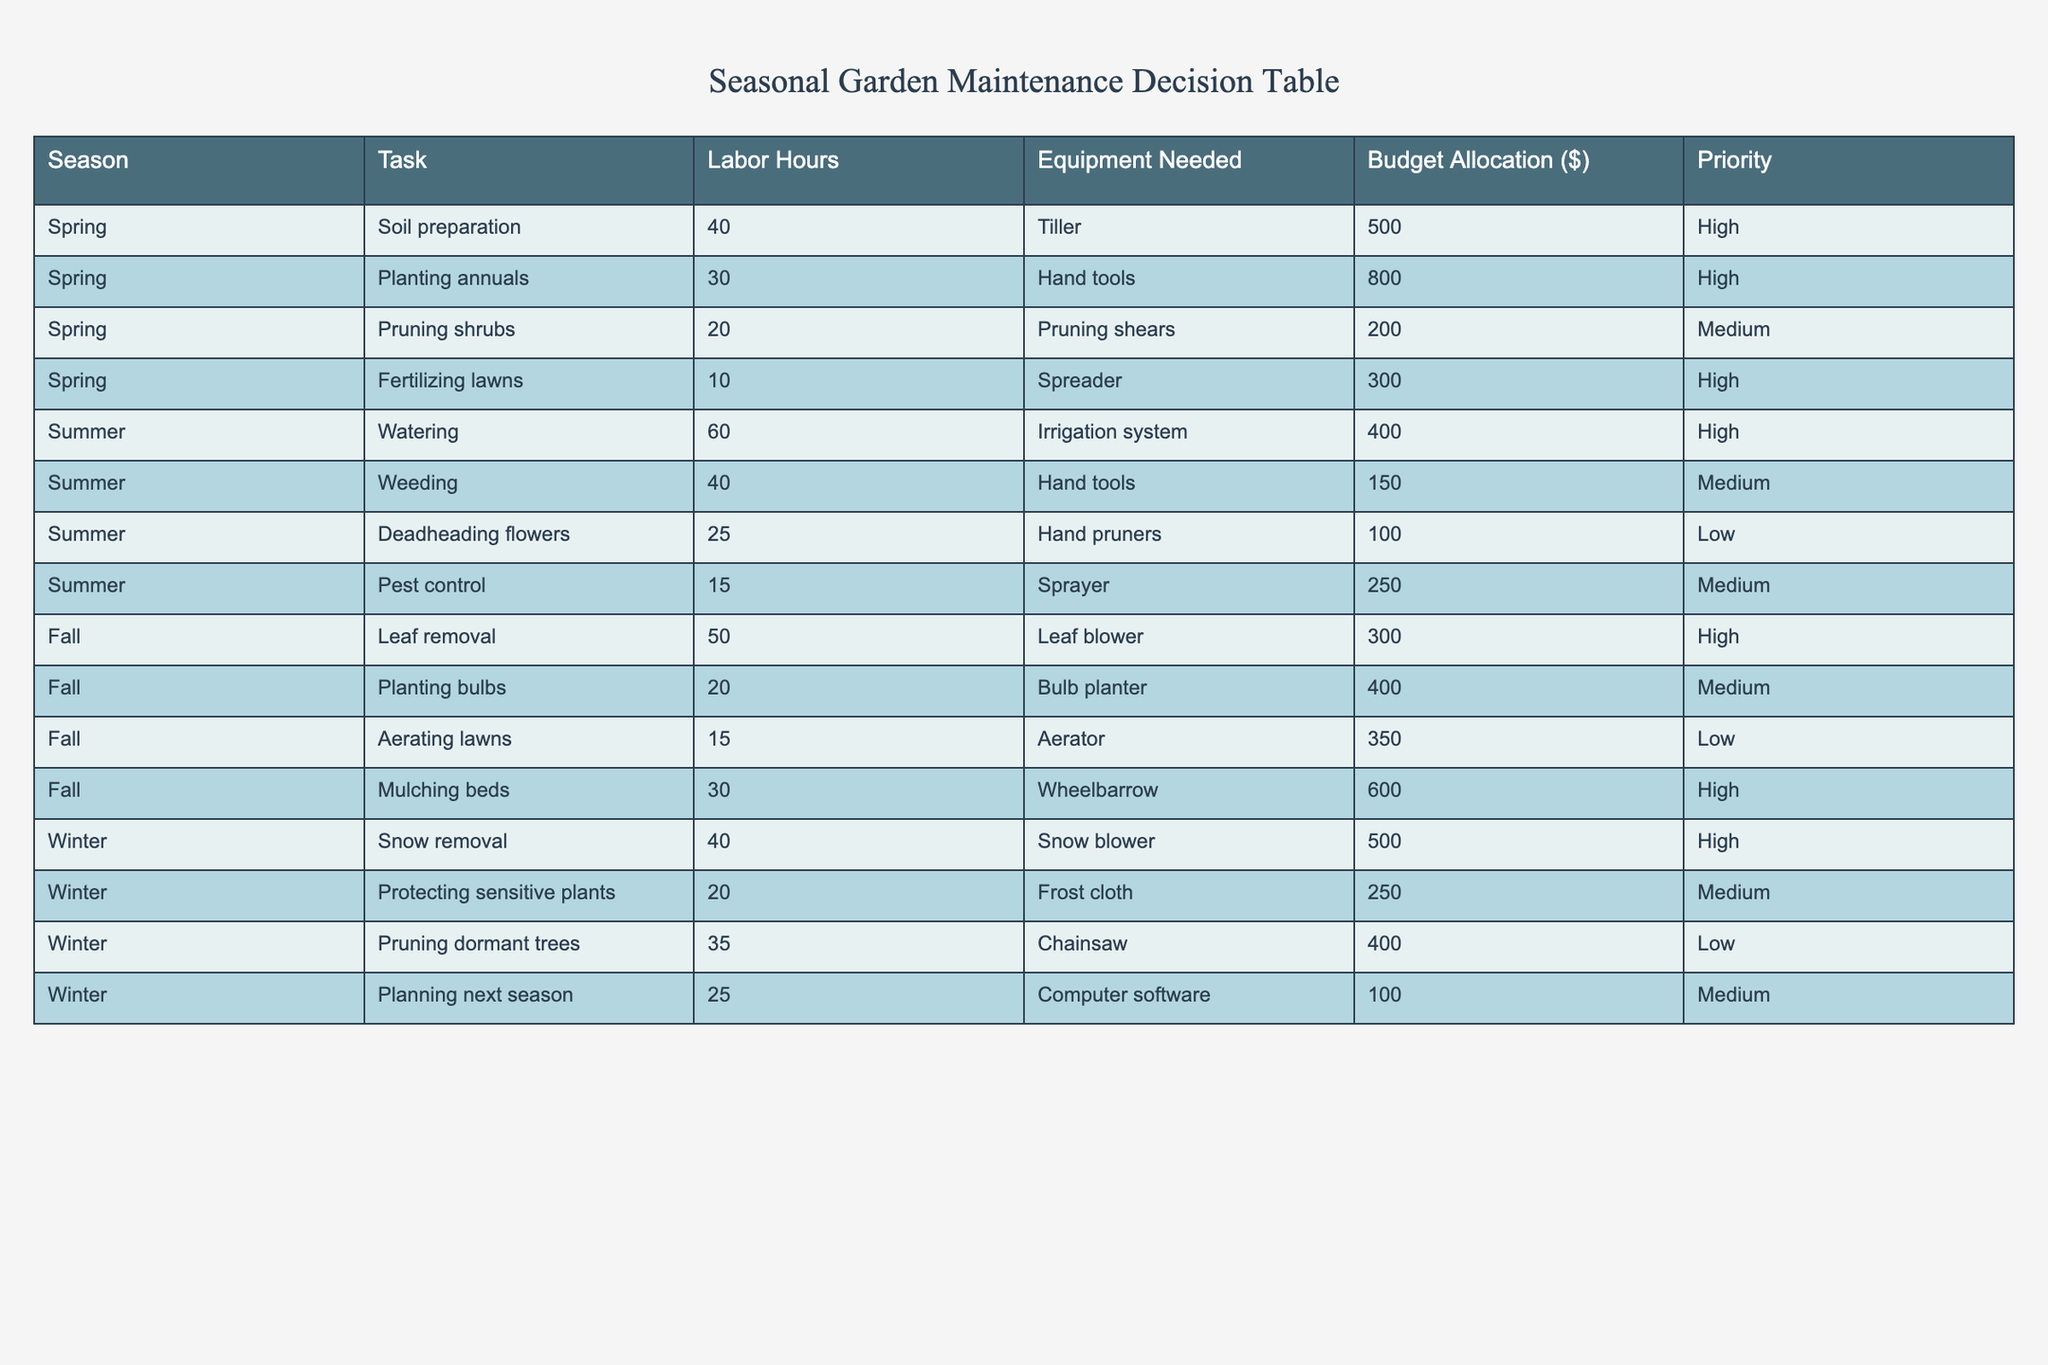What is the total budget allocation for Spring tasks? To find the total budget allocation for Spring tasks, we look at the Budget Allocation column for the rows where the Season is Spring: 500 (Soil preparation) + 800 (Planting annuals) + 200 (Pruning shrubs) + 300 (Fertilizing lawns) = 1800.
Answer: 1800 Which task requires the least labor hours in Summer? For Summer, we check the Labor Hours column and identify the tasks: Watering (60), Weeding (40), Deadheading flowers (25), and Pest control (15). The task with the least labor hours is Pest control with 15 hours.
Answer: Pest control Is "Pruning shrubs" a high-priority task? By checking the Priority column for "Pruning shrubs," it is stated as Medium priority, so it is not classified as High priority.
Answer: No How many tasks in Fall have a Medium priority? In Fall, we look at the tasks: Leaf removal is High, Planting bulbs is Medium, Aerating lawns is Low, and Mulching beds is High. Only one task, Planting bulbs, is classified as Medium priority.
Answer: 1 What is the average budget allocation for Winter tasks? The budget allocation for Winter tasks is 500 (Snow removal) + 250 (Protecting sensitive plants) + 400 (Pruning dormant trees) + 100 (Planning next season) = 1250. There are 4 Winter tasks, so the average is 1250 / 4 = 312.5.
Answer: 312.5 Which season has the highest total labor hours across all tasks? We sum the Labor Hours for each season: Spring (100), Summer (140), Fall (95), and Winter (95). Summer has the highest total labor hours of 140.
Answer: Summer Is "Fertilizing lawns" a task that requires hand tools? Checking the Equipment Needed column, "Fertilizing lawns" requires a Spreader, not hand tools, so it does not qualify.
Answer: No What is the total labor hours for tasks that have High priority in Spring? In Spring, we list the High priority tasks: Soil preparation (40 hours), Planting annuals (30 hours), and Fertilizing lawns (10 hours). The total labor hours is 40 + 30 + 10 = 80.
Answer: 80 